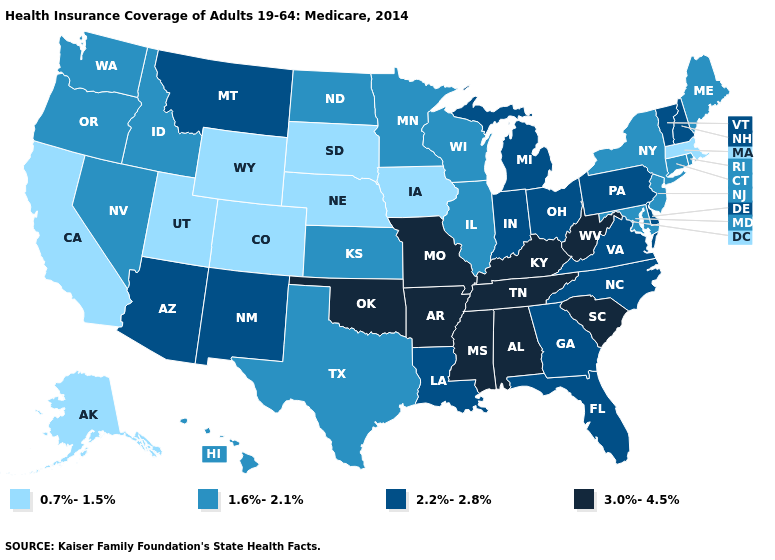What is the value of Kansas?
Answer briefly. 1.6%-2.1%. Name the states that have a value in the range 2.2%-2.8%?
Give a very brief answer. Arizona, Delaware, Florida, Georgia, Indiana, Louisiana, Michigan, Montana, New Hampshire, New Mexico, North Carolina, Ohio, Pennsylvania, Vermont, Virginia. What is the value of North Dakota?
Answer briefly. 1.6%-2.1%. What is the value of Florida?
Give a very brief answer. 2.2%-2.8%. Name the states that have a value in the range 1.6%-2.1%?
Quick response, please. Connecticut, Hawaii, Idaho, Illinois, Kansas, Maine, Maryland, Minnesota, Nevada, New Jersey, New York, North Dakota, Oregon, Rhode Island, Texas, Washington, Wisconsin. Which states have the highest value in the USA?
Short answer required. Alabama, Arkansas, Kentucky, Mississippi, Missouri, Oklahoma, South Carolina, Tennessee, West Virginia. How many symbols are there in the legend?
Quick response, please. 4. Among the states that border New York , which have the lowest value?
Short answer required. Massachusetts. Among the states that border Wisconsin , does Michigan have the highest value?
Keep it brief. Yes. Name the states that have a value in the range 1.6%-2.1%?
Give a very brief answer. Connecticut, Hawaii, Idaho, Illinois, Kansas, Maine, Maryland, Minnesota, Nevada, New Jersey, New York, North Dakota, Oregon, Rhode Island, Texas, Washington, Wisconsin. Does New York have the highest value in the Northeast?
Give a very brief answer. No. Name the states that have a value in the range 0.7%-1.5%?
Concise answer only. Alaska, California, Colorado, Iowa, Massachusetts, Nebraska, South Dakota, Utah, Wyoming. Which states hav the highest value in the South?
Give a very brief answer. Alabama, Arkansas, Kentucky, Mississippi, Oklahoma, South Carolina, Tennessee, West Virginia. What is the highest value in the USA?
Concise answer only. 3.0%-4.5%. Does North Carolina have the same value as Tennessee?
Give a very brief answer. No. 